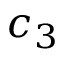Convert formula to latex. <formula><loc_0><loc_0><loc_500><loc_500>c _ { 3 }</formula> 